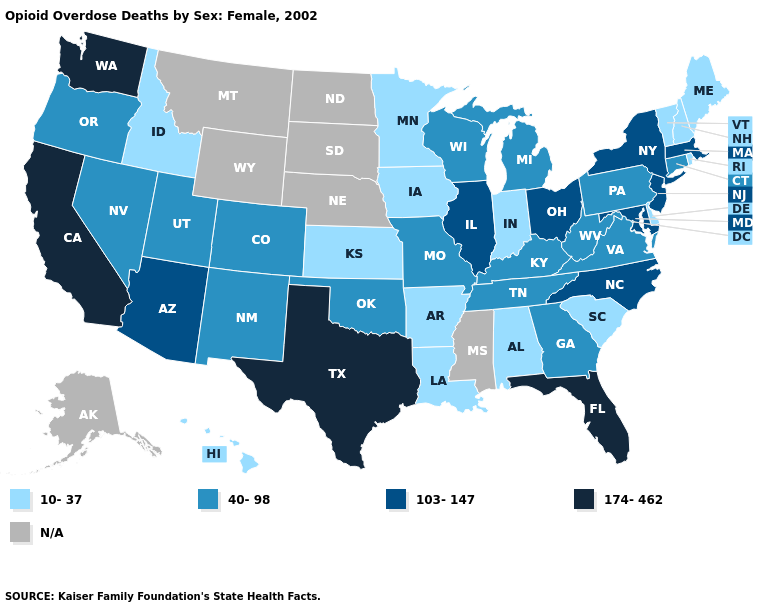What is the highest value in the South ?
Answer briefly. 174-462. Does the first symbol in the legend represent the smallest category?
Answer briefly. Yes. Is the legend a continuous bar?
Keep it brief. No. Name the states that have a value in the range 174-462?
Quick response, please. California, Florida, Texas, Washington. What is the highest value in states that border Alabama?
Give a very brief answer. 174-462. Name the states that have a value in the range 10-37?
Write a very short answer. Alabama, Arkansas, Delaware, Hawaii, Idaho, Indiana, Iowa, Kansas, Louisiana, Maine, Minnesota, New Hampshire, Rhode Island, South Carolina, Vermont. Does the first symbol in the legend represent the smallest category?
Keep it brief. Yes. What is the value of Minnesota?
Concise answer only. 10-37. Among the states that border New Jersey , which have the highest value?
Give a very brief answer. New York. Does California have the highest value in the USA?
Be succinct. Yes. Which states have the lowest value in the USA?
Answer briefly. Alabama, Arkansas, Delaware, Hawaii, Idaho, Indiana, Iowa, Kansas, Louisiana, Maine, Minnesota, New Hampshire, Rhode Island, South Carolina, Vermont. What is the value of Kentucky?
Short answer required. 40-98. Which states have the lowest value in the MidWest?
Keep it brief. Indiana, Iowa, Kansas, Minnesota. What is the highest value in the MidWest ?
Answer briefly. 103-147. 